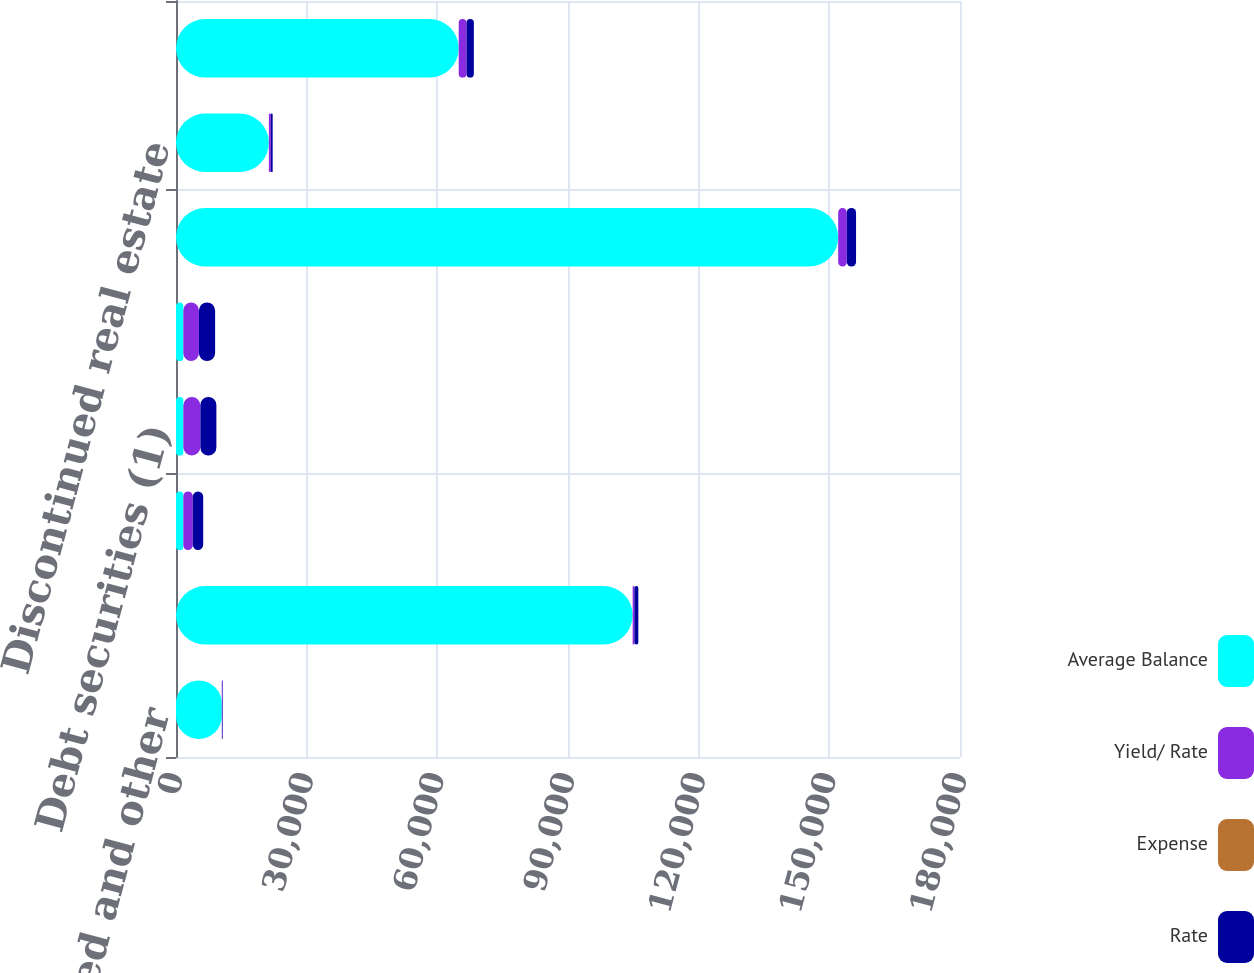<chart> <loc_0><loc_0><loc_500><loc_500><stacked_bar_chart><ecel><fcel>Time deposits placed and other<fcel>Federal funds sold and<fcel>Trading account assets<fcel>Debt securities (1)<fcel>Residential mortgage<fcel>Home equity<fcel>Discontinued real estate<fcel>Credit card - domestic<nl><fcel>Average Balance<fcel>10511<fcel>104843<fcel>1682<fcel>1682<fcel>1682<fcel>152035<fcel>21324<fcel>64906<nl><fcel>Yield/ Rate<fcel>158<fcel>393<fcel>2170<fcel>3913<fcel>3581<fcel>1969<fcel>459<fcel>1784<nl><fcel>Expense<fcel>5.97<fcel>1.5<fcel>4.21<fcel>5.57<fcel>5.65<fcel>5.17<fcel>8.6<fcel>10.94<nl><fcel>Rate<fcel>101<fcel>912<fcel>2390<fcel>3672<fcel>3712<fcel>2124<fcel>399<fcel>1682<nl></chart> 